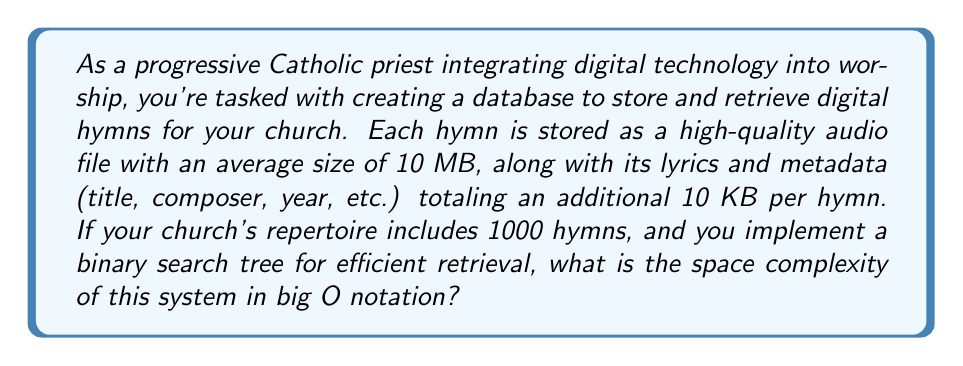Give your solution to this math problem. To determine the space complexity, we need to consider all components of the system:

1. Audio files:
   - Each audio file is 10 MB = $10 \times 10^6$ bytes
   - Total for 1000 hymns: $1000 \times 10 \times 10^6 = 10^{10}$ bytes

2. Lyrics and metadata:
   - Each hymn's additional data is 10 KB = $10 \times 10^3$ bytes
   - Total for 1000 hymns: $1000 \times 10 \times 10^3 = 10^7$ bytes

3. Binary Search Tree (BST) structure:
   - A BST node typically contains the data (or a pointer to the data) and two pointers (left and right child)
   - Assuming 64-bit system, each pointer is 8 bytes
   - Each node: 8 (data pointer) + 8 (left pointer) + 8 (right pointer) = 24 bytes
   - Total for 1000 nodes: $1000 \times 24 = 2.4 \times 10^4$ bytes

Total space: $10^{10} + 10^7 + 2.4 \times 10^4 \approx 10^{10}$ bytes

In terms of the number of hymns $n$:
- Audio files: $O(n)$
- Lyrics and metadata: $O(n)$
- BST structure: $O(n)$

The dominant term is the audio files, which scales linearly with the number of hymns. Therefore, the overall space complexity is $O(n)$.
Answer: $O(n)$, where $n$ is the number of hymns in the database. 